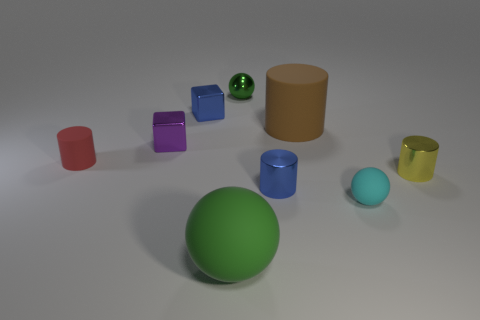Subtract all blocks. How many objects are left? 7 Add 3 small metallic blocks. How many small metallic blocks are left? 5 Add 5 purple things. How many purple things exist? 6 Subtract 0 gray blocks. How many objects are left? 9 Subtract all yellow rubber things. Subtract all tiny purple cubes. How many objects are left? 8 